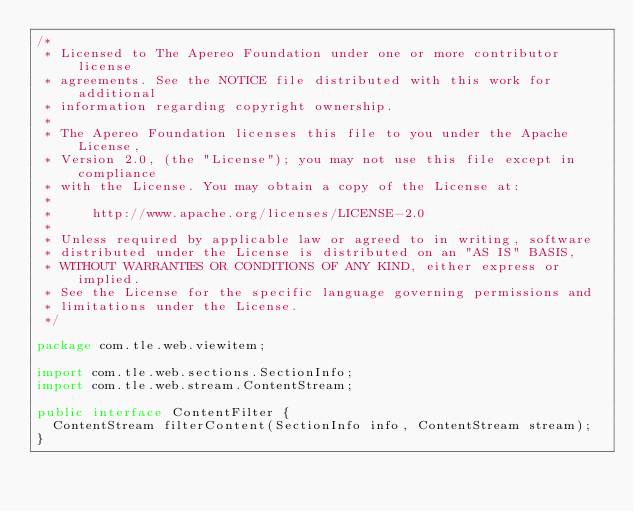Convert code to text. <code><loc_0><loc_0><loc_500><loc_500><_Java_>/*
 * Licensed to The Apereo Foundation under one or more contributor license
 * agreements. See the NOTICE file distributed with this work for additional
 * information regarding copyright ownership.
 *
 * The Apereo Foundation licenses this file to you under the Apache License,
 * Version 2.0, (the "License"); you may not use this file except in compliance
 * with the License. You may obtain a copy of the License at:
 *
 *     http://www.apache.org/licenses/LICENSE-2.0
 *
 * Unless required by applicable law or agreed to in writing, software
 * distributed under the License is distributed on an "AS IS" BASIS,
 * WITHOUT WARRANTIES OR CONDITIONS OF ANY KIND, either express or implied.
 * See the License for the specific language governing permissions and
 * limitations under the License.
 */

package com.tle.web.viewitem;

import com.tle.web.sections.SectionInfo;
import com.tle.web.stream.ContentStream;

public interface ContentFilter {
  ContentStream filterContent(SectionInfo info, ContentStream stream);
}
</code> 